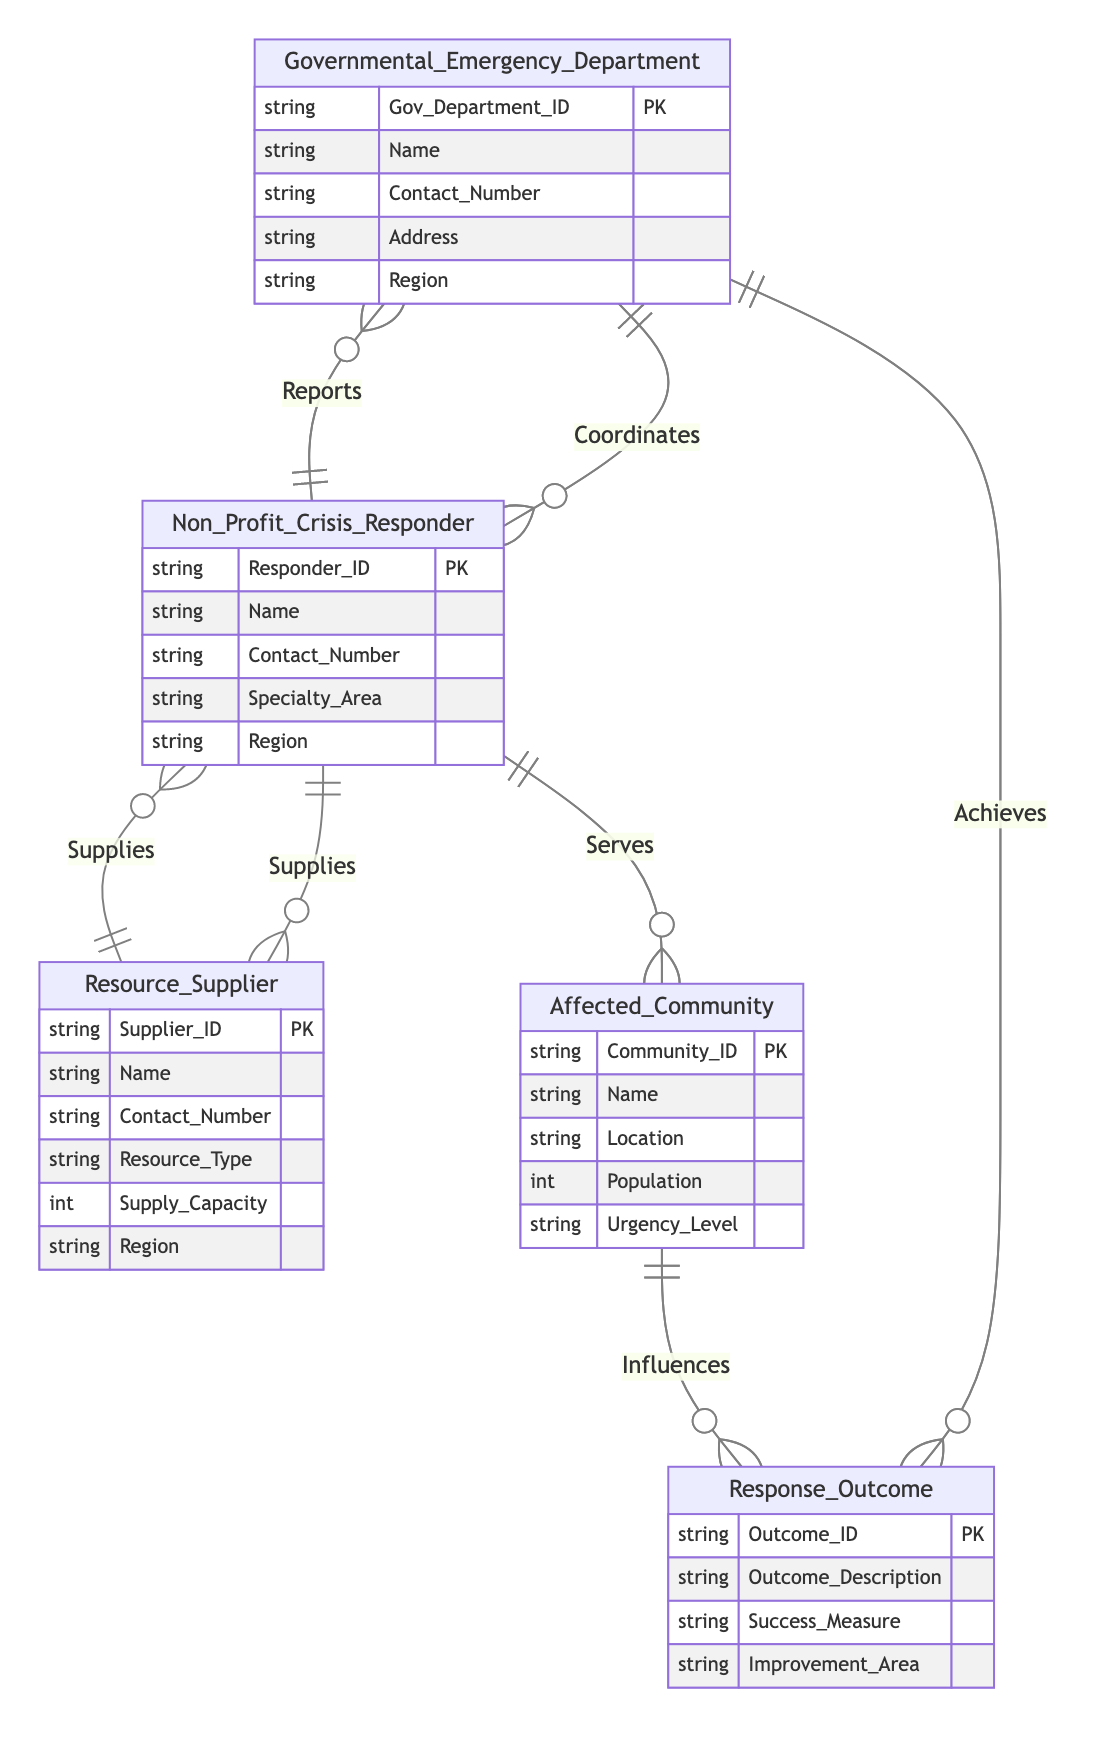What is the primary relationship between Governmental Emergency Department and Non-Profit Crisis Responder? The primary relationship is "Coordinates," which indicates how these two entities interact in coordinating their efforts during health emergencies.
Answer: Coordinates How many entities are involved in this ER diagram? The ER diagram features five entities, namely Governmental Emergency Department, Non-Profit Crisis Responder, Resource Supplier, Affected Community, and Response Outcome.
Answer: Five What attribute is used to identify a Resource Supplier? The identifying attribute for a Resource Supplier is "Supplier_ID," which serves as the primary key for this entity.
Answer: Supplier_ID Which entity influences the Response Outcome? The entity that influences the Response Outcome is the "Affected Community," showing its impact on the outcomes of emergency responses.
Answer: Affected Community What attributes connect Non-Profit Crisis Responder and Resource Supplier? The attributes that connect Non-Profit Crisis Responder and Resource Supplier are "Supply_Quantity" and "Delivery_Date," indicating the details of supplies provided by the supplier.
Answer: Supply_Quantity, Delivery_Date Which entity achieves the Response Outcome? The entity responsible for achieving the Response Outcome is the "Governmental Emergency Department," indicating its role in attaining positive results from emergency interventions.
Answer: Governmental Emergency Department Describe the nature of the relationship between Affected Community and Response Outcome. The relationship is termed "Influences," highlighting how the condition and needs of the affected community can impact the overall outcomes of the health emergency response efforts.
Answer: Influences What is the significance of the Coordination Level attribute? The "Coordination Level" attribute reflects the degree of collaboration between the Governmental Emergency Department and Non-Profit Crisis Responder, indicating how well their efforts are aligned during health emergencies.
Answer: Coordination Level How does Non-Profit Crisis Responder serve Affected Community? Non-Profit Crisis Responder serves Affected Community through a relationship called "Serves," detailing the types of services provided and when these services occur.
Answer: Serves 